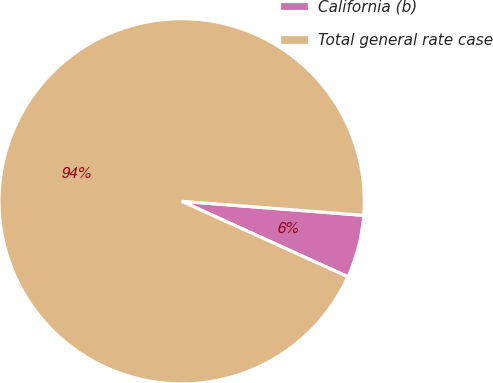Convert chart. <chart><loc_0><loc_0><loc_500><loc_500><pie_chart><fcel>California (b)<fcel>Total general rate case<nl><fcel>5.56%<fcel>94.44%<nl></chart> 